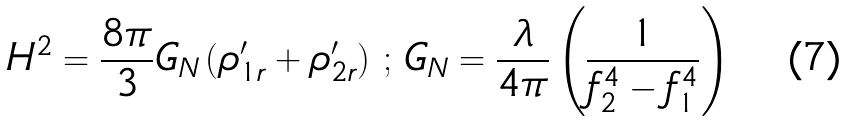Convert formula to latex. <formula><loc_0><loc_0><loc_500><loc_500>H ^ { 2 } = \frac { 8 \pi } { 3 } G _ { N } \left ( \rho _ { 1 r } ^ { \prime } + \rho _ { 2 r } ^ { \prime } \right ) \, ; \, G _ { N } = \frac { \lambda } { 4 \pi } \left ( \frac { 1 } { f _ { 2 } ^ { 4 } - f _ { 1 } ^ { 4 } } \right )</formula> 